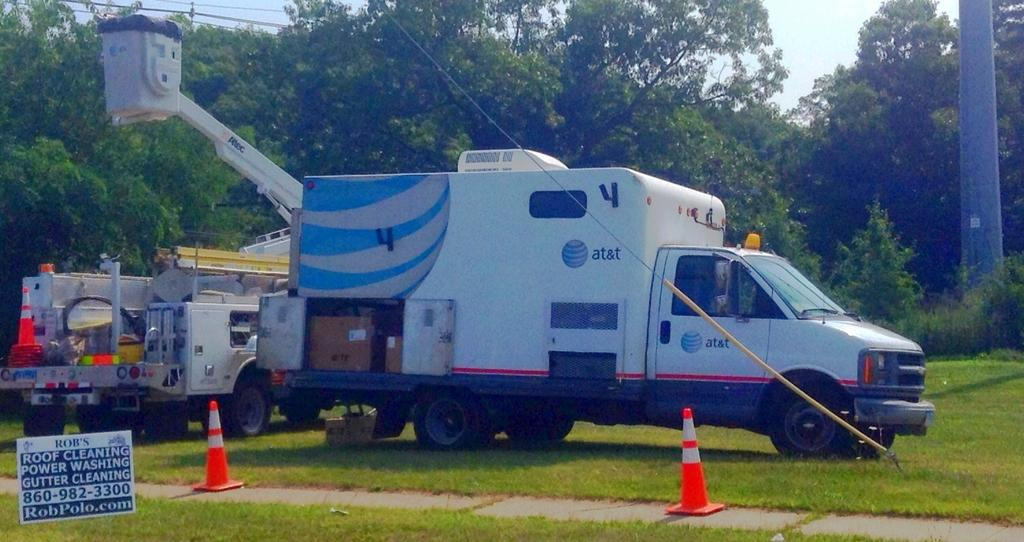Provide a one-sentence caption for the provided image. a large with van with cherry picker in the background, can has at&t on it. 